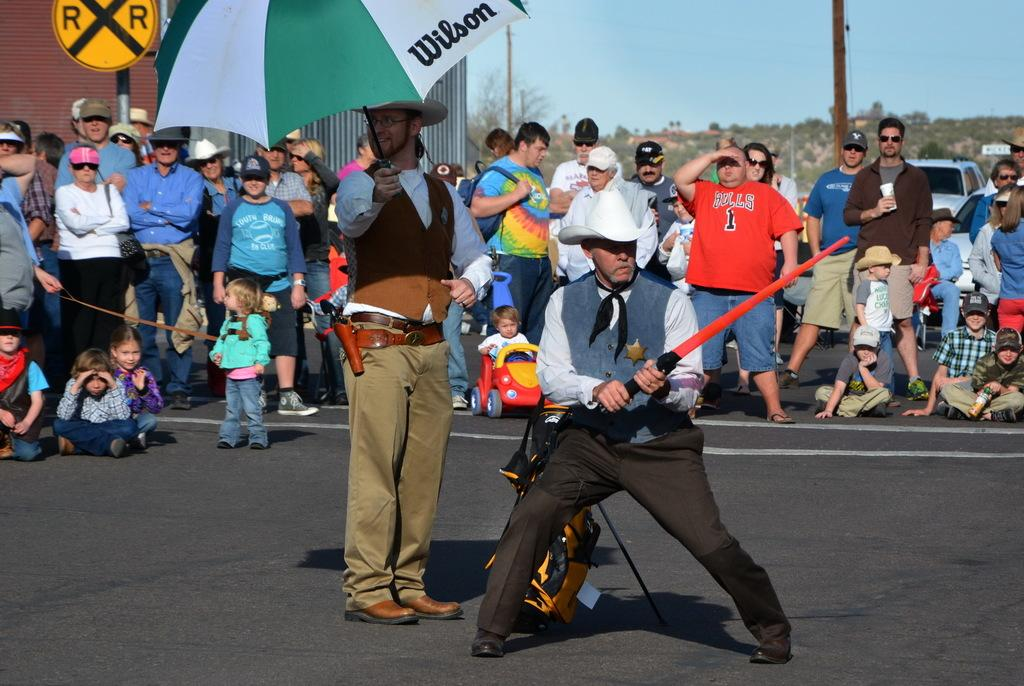Who or what is present in the image? There are people in the image. What object can be seen in the image that is typically associated with play? There is a toy car in the image. What object is present in the image that can provide shade or protection from the rain? There is an umbrella in the image. What type of structures can be seen in the image? There are buildings in the image. What architectural feature is present in the image? There is a sign pole in the image. What type of vegetation is visible in the image? There are trees in the image. What part of the natural environment is visible in the image? The sky is visible in the image. What type of ray is swimming in the image? There is no ray present in the image. Who is the uncle of the people in the image? There is no information about an uncle in the image. 